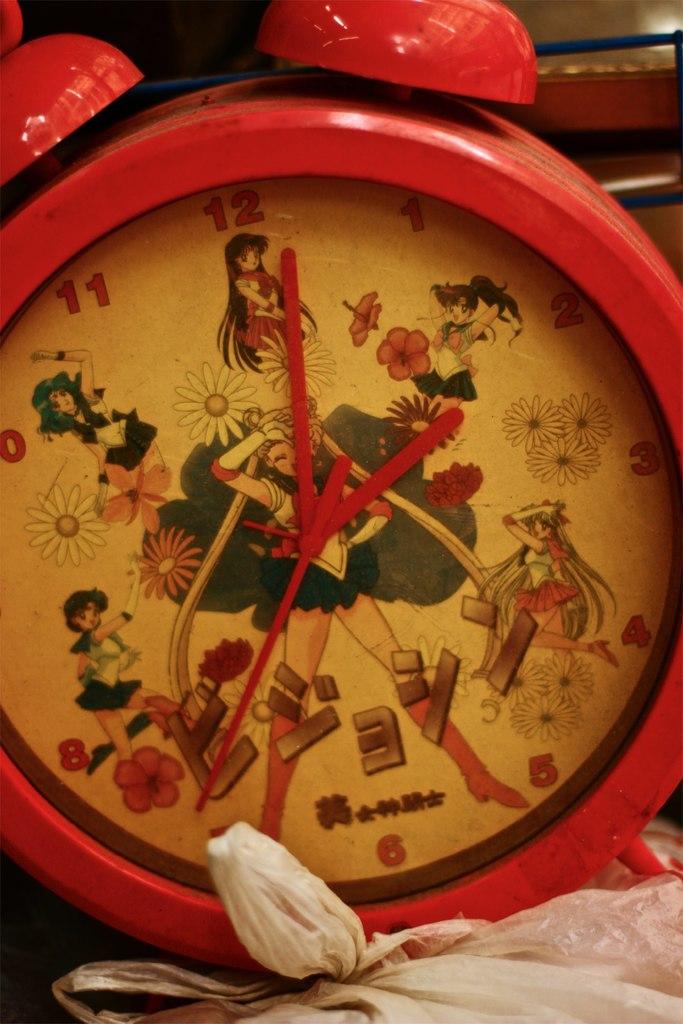What time is it, according to the clock?
Your response must be concise. 2:01. 